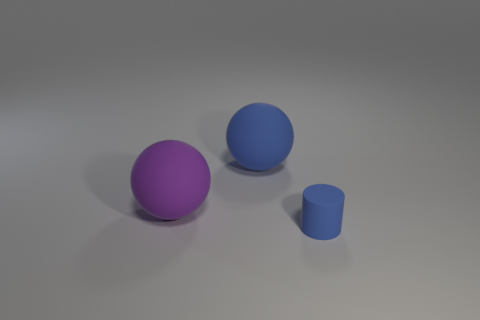How many objects are there in the image? There are three objects in the image: two spherical shapes and one cylindrical shape. 